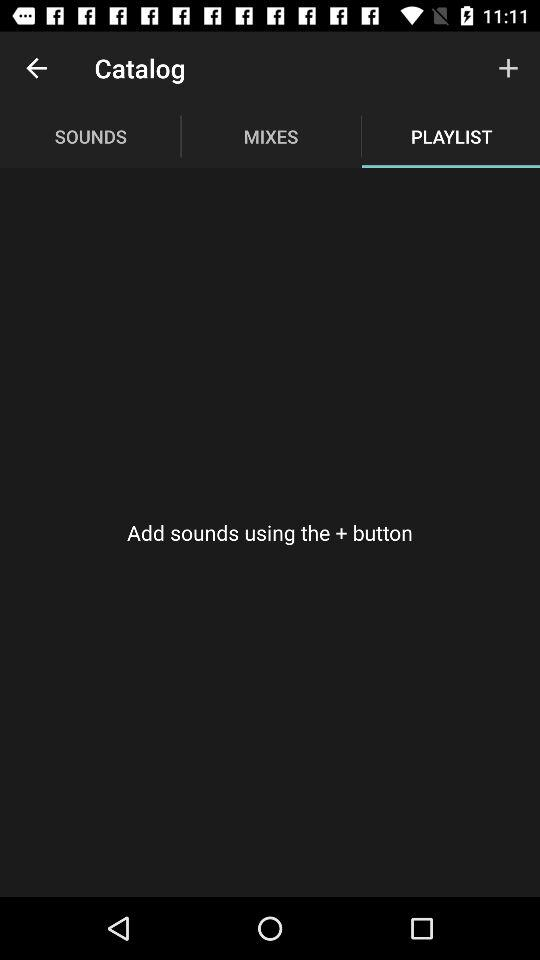Which tab is selected? The selected tab is "PLAYLIST". 